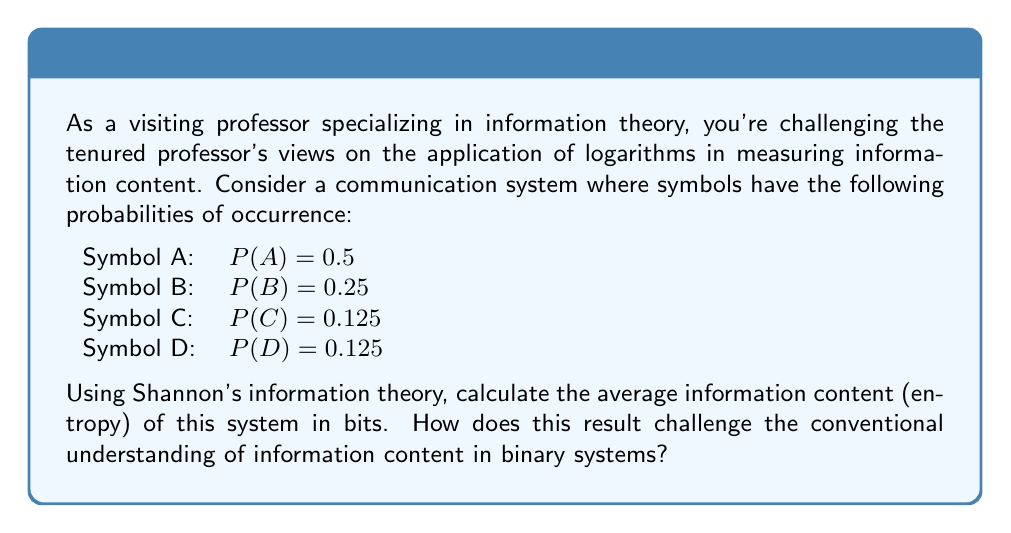Could you help me with this problem? To solve this problem, we'll use Shannon's entropy formula, which is fundamental in information theory:

$$H = -\sum_{i=1}^n P(x_i) \log_2 P(x_i)$$

Where $H$ is the entropy, $P(x_i)$ is the probability of symbol $x_i$, and $\log_2$ is used because we want the result in bits.

Let's calculate for each symbol:

1) For A: $-0.5 \log_2(0.5) = 0.5$
2) For B: $-0.25 \log_2(0.25) = 0.5$
3) For C: $-0.125 \log_2(0.125) = 0.375$
4) For D: $-0.125 \log_2(0.125) = 0.375$

Now, sum these values:

$$H = 0.5 + 0.5 + 0.375 + 0.375 = 1.75\text{ bits}$$

This result challenges conventional understanding because:

1) In a binary system, we might expect the entropy to be an integer number of bits.
2) With four symbols, a naive approach might suggest 2 bits of information ($\log_2(4) = 2$).
3) The non-uniform probabilities lead to an entropy less than 2, showing that the system is more predictable and thus contains less information than a system with equally likely symbols.

This demonstrates how logarithms in information theory can provide a more nuanced understanding of information content, taking into account the actual probabilities of symbols rather than just the number of possible symbols.
Answer: The average information content (entropy) of the system is 1.75 bits. 